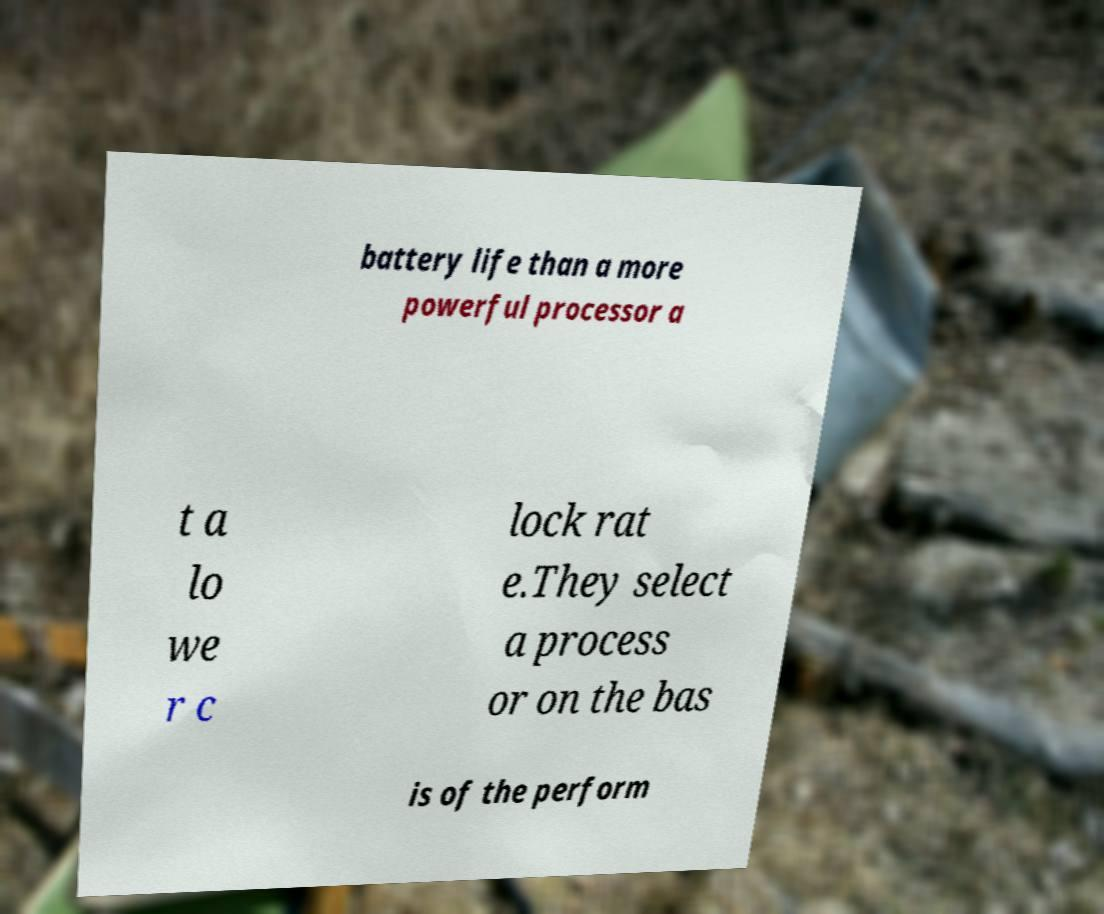Can you read and provide the text displayed in the image?This photo seems to have some interesting text. Can you extract and type it out for me? battery life than a more powerful processor a t a lo we r c lock rat e.They select a process or on the bas is of the perform 